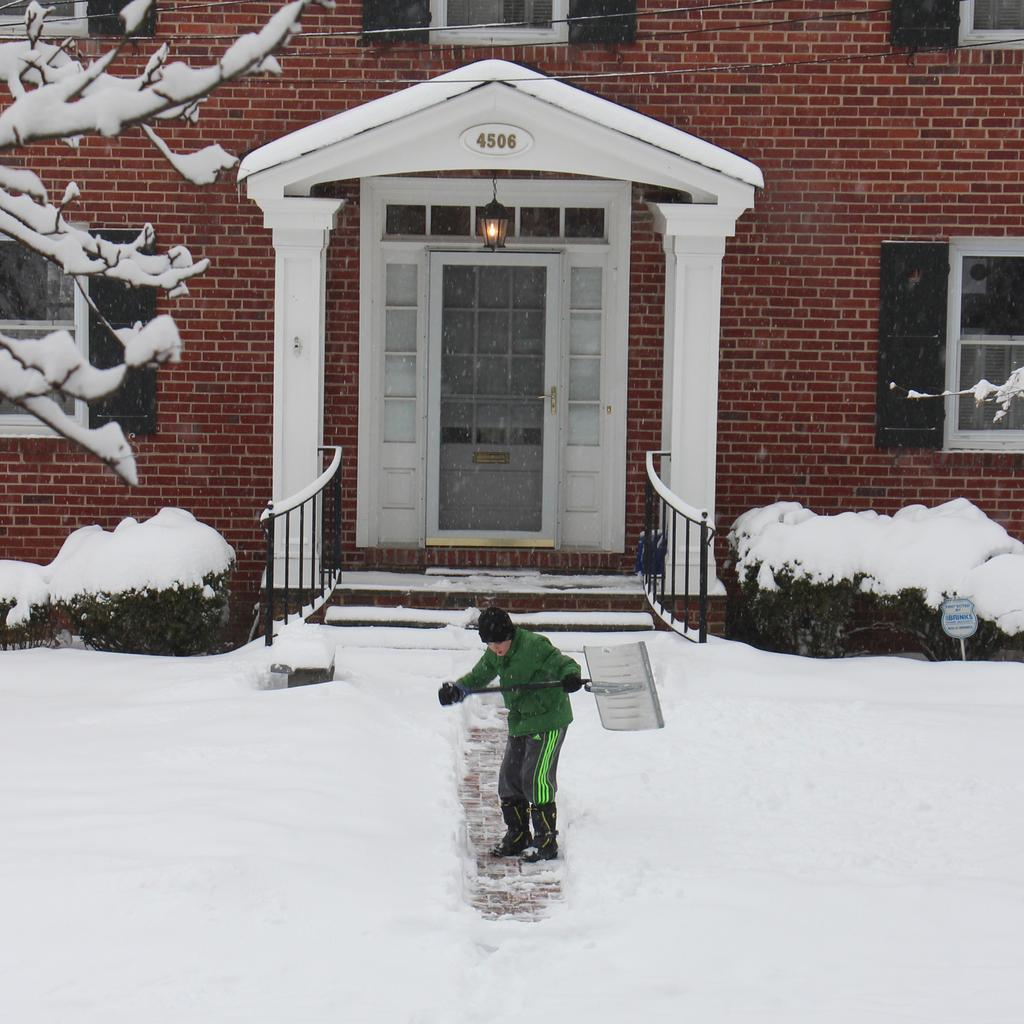What is the main subject of the image? The main subject of the image is a man. What is the man doing in the image? The man is standing on the ice in the image. What is the man holding in his hands? The man is holding an object in his hands. What can be seen in the background of the image? In the background of the image, there are plants, trees, light, and a house. What type of humor can be seen in the man's facial expression in the image? There is no indication of humor or a specific facial expression in the man's face in the image. What type of dog is present in the image? There is no dog present in the image. 